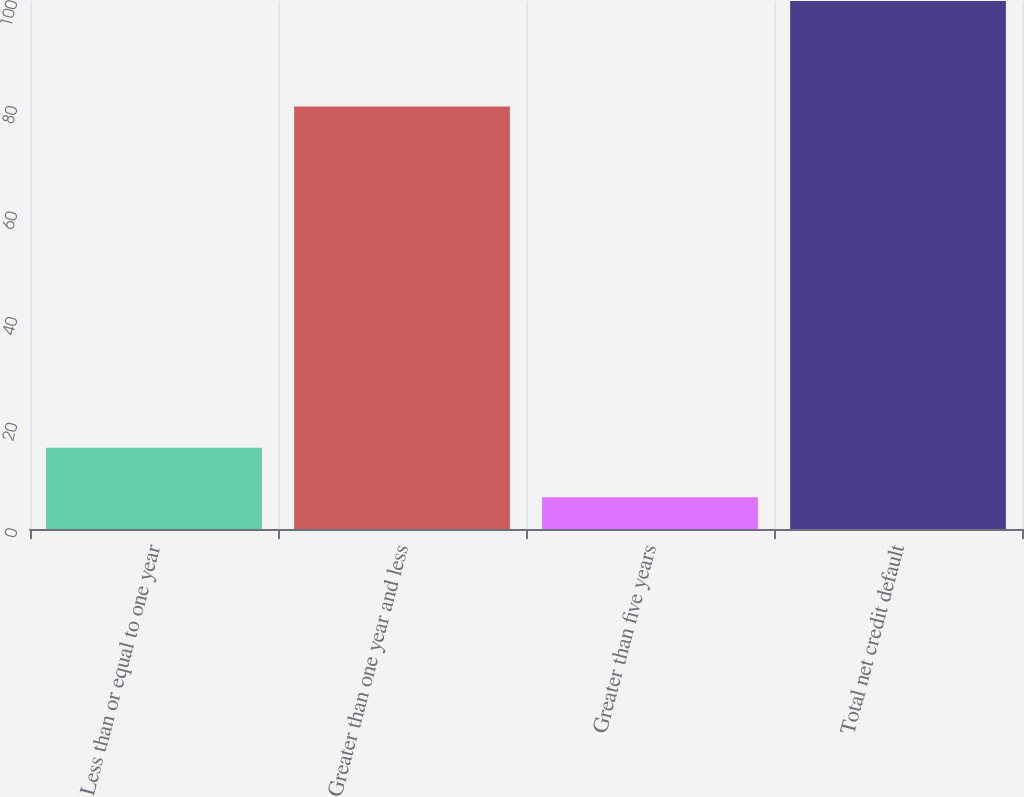Convert chart. <chart><loc_0><loc_0><loc_500><loc_500><bar_chart><fcel>Less than or equal to one year<fcel>Greater than one year and less<fcel>Greater than five years<fcel>Total net credit default<nl><fcel>15.4<fcel>80<fcel>6<fcel>100<nl></chart> 